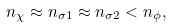<formula> <loc_0><loc_0><loc_500><loc_500>n _ { \chi } \approx n _ { \sigma 1 } \approx n _ { \sigma 2 } < n _ { \phi } ,</formula> 